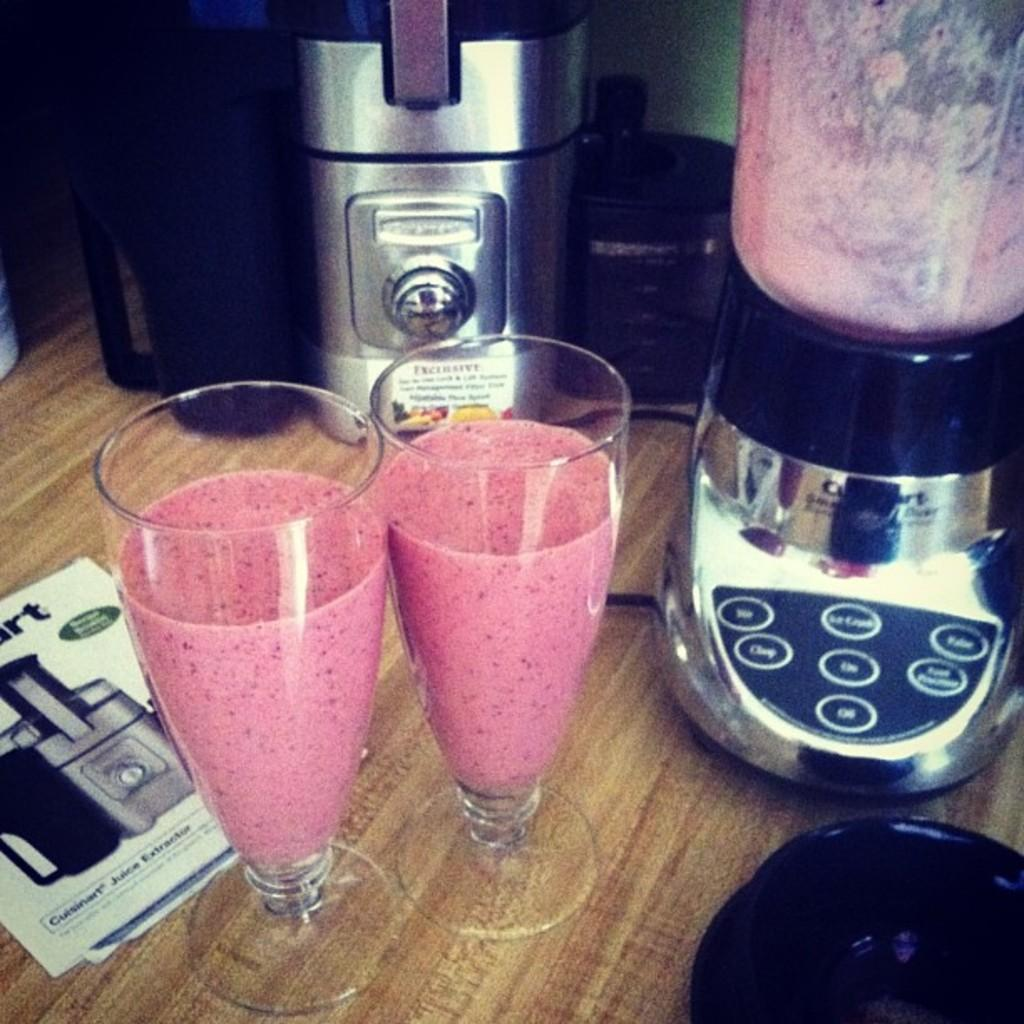<image>
Write a terse but informative summary of the picture. a couple of glasses next to a Cuisinart pamphlet 